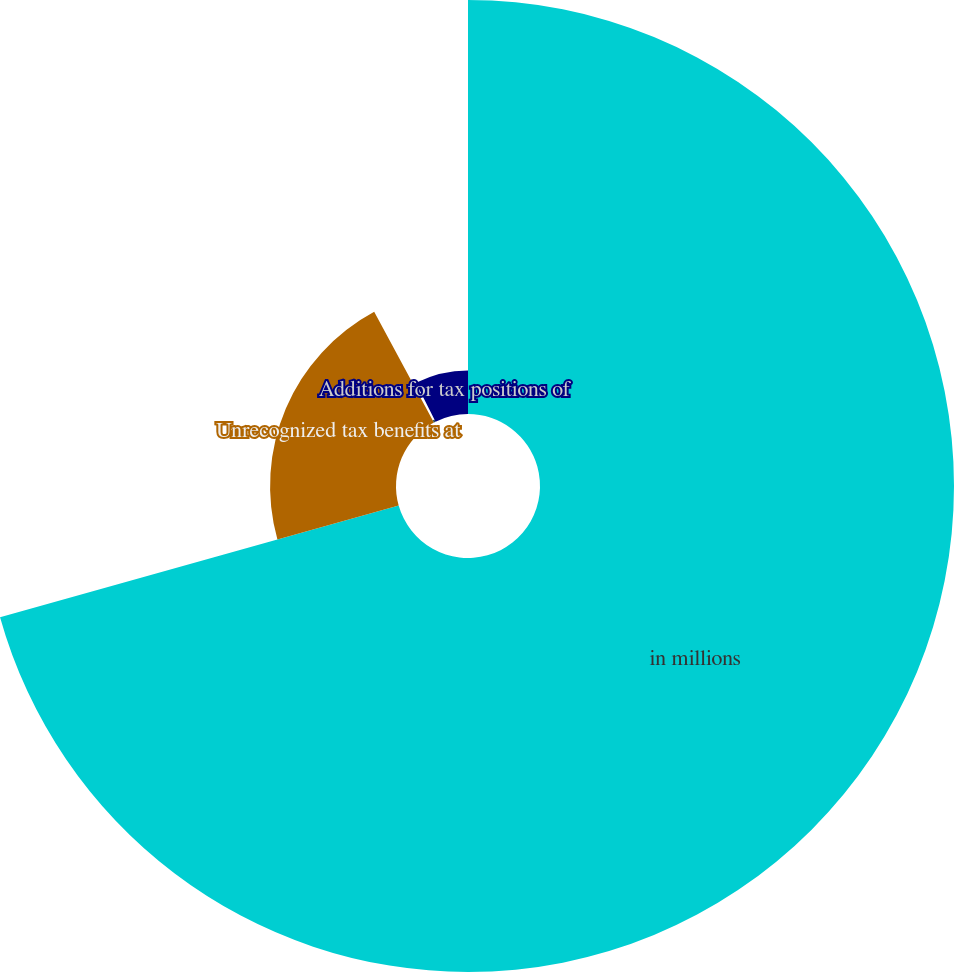Convert chart to OTSL. <chart><loc_0><loc_0><loc_500><loc_500><pie_chart><fcel>in millions<fcel>Unrecognized tax benefits at<fcel>Additions based on tax<fcel>Additions for tax positions of<nl><fcel>70.65%<fcel>21.49%<fcel>0.42%<fcel>7.44%<nl></chart> 